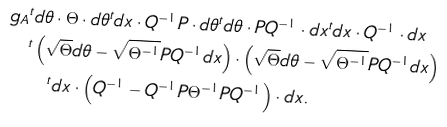<formula> <loc_0><loc_0><loc_500><loc_500>g _ { A } & ^ { t } d \theta \cdot \Theta \cdot d \theta ^ { t } d x \cdot Q ^ { - 1 } P \cdot d \theta ^ { t } d \theta \cdot P Q ^ { - 1 } \cdot d x ^ { t } d x \cdot Q ^ { - 1 } \cdot d x \\ & ^ { t } \left ( \sqrt { \Theta } d \theta - \sqrt { \Theta ^ { - 1 } } P Q ^ { - 1 } d x \right ) \cdot \left ( \sqrt { \Theta } d \theta - \sqrt { \Theta ^ { - 1 } } P Q ^ { - 1 } d x \right ) \\ & \quad ^ { t } d x \cdot \left ( Q ^ { - 1 } - Q ^ { - 1 } P \Theta ^ { - 1 } P Q ^ { - 1 } \right ) \cdot d x .</formula> 